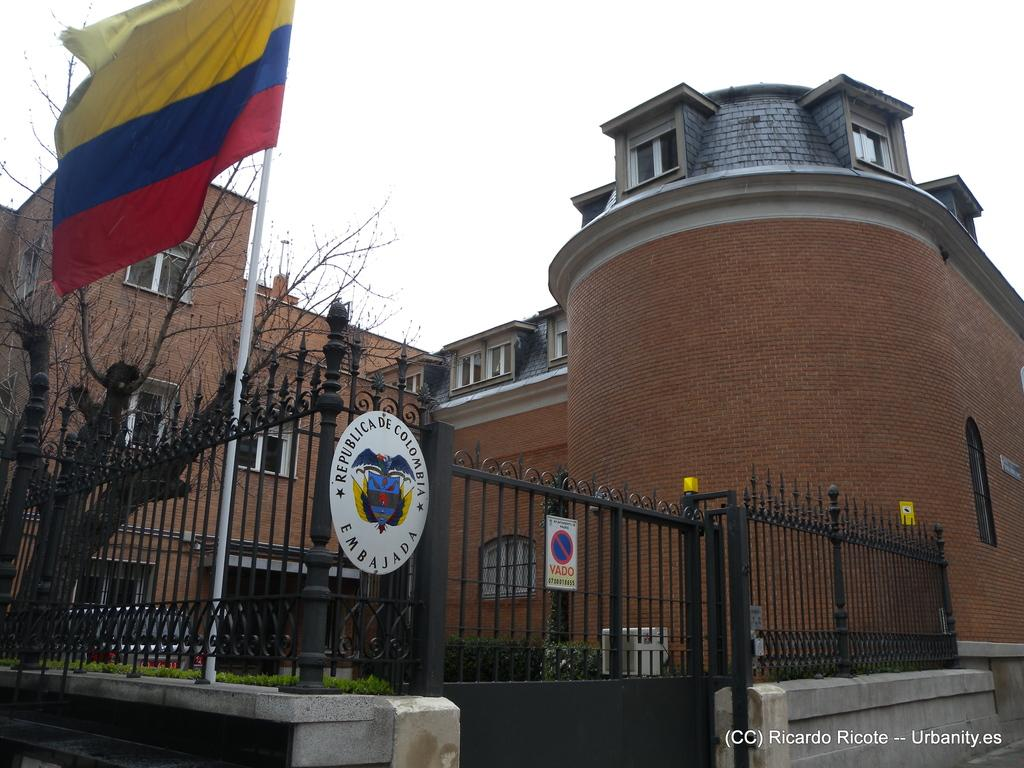What type of structure is visible in the image? There is a building in the image. What can be seen on the left side of the image? There is a tree on the left side of the image. What is present near the building in the image? There is a flag pole in the image. What type of barrier surrounds the building in the image? There is a metal fence with a metal gate in the image. Where is the text located in the image? The text is at the bottom right corner of the image. How would you describe the weather in the image? The sky is cloudy in the image. What type of ant can be seen climbing the building in the image? There are no ants present in the image; it only features a building, a tree, a flag pole, a metal fence, text, and a cloudy sky. 